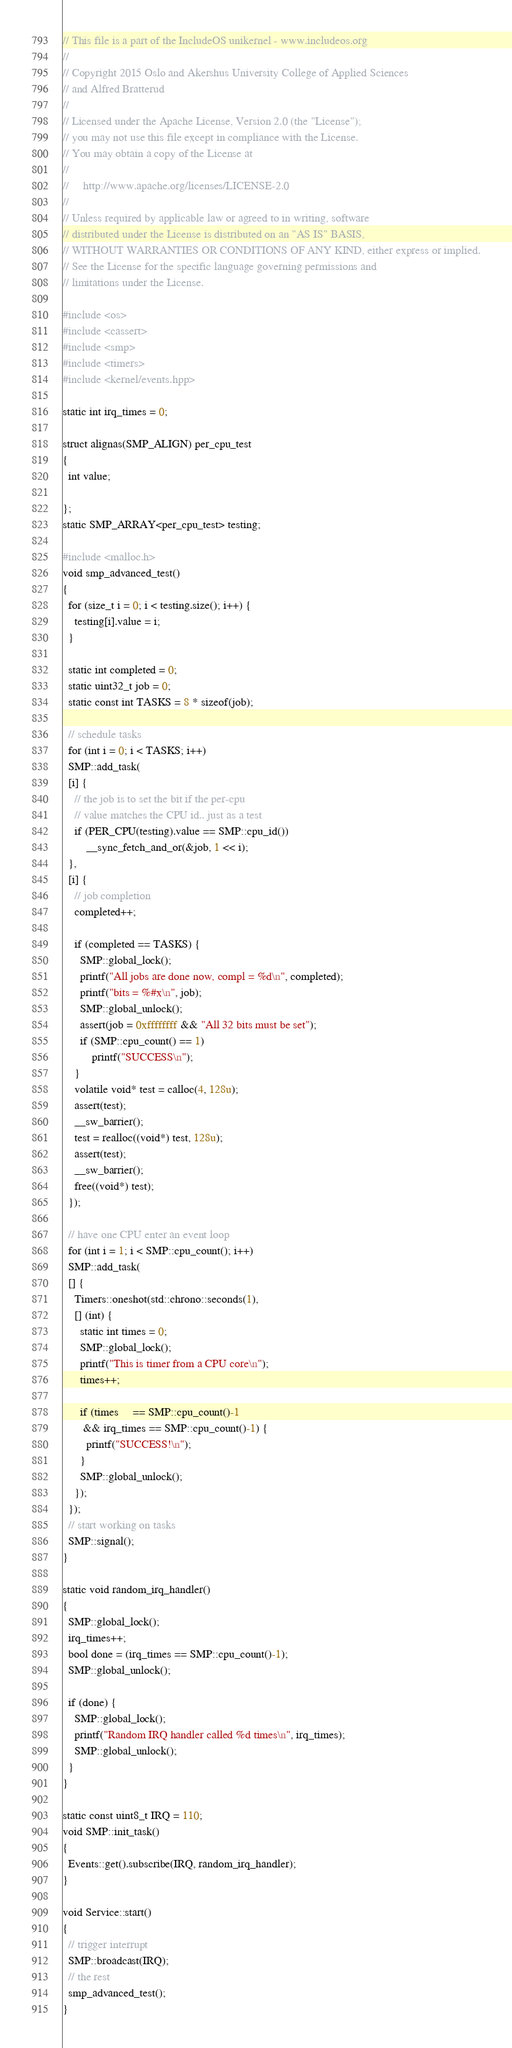Convert code to text. <code><loc_0><loc_0><loc_500><loc_500><_C++_>// This file is a part of the IncludeOS unikernel - www.includeos.org
//
// Copyright 2015 Oslo and Akershus University College of Applied Sciences
// and Alfred Bratterud
//
// Licensed under the Apache License, Version 2.0 (the "License");
// you may not use this file except in compliance with the License.
// You may obtain a copy of the License at
//
//     http://www.apache.org/licenses/LICENSE-2.0
//
// Unless required by applicable law or agreed to in writing, software
// distributed under the License is distributed on an "AS IS" BASIS,
// WITHOUT WARRANTIES OR CONDITIONS OF ANY KIND, either express or implied.
// See the License for the specific language governing permissions and
// limitations under the License.

#include <os>
#include <cassert>
#include <smp>
#include <timers>
#include <kernel/events.hpp>

static int irq_times = 0;

struct alignas(SMP_ALIGN) per_cpu_test
{
  int value;

};
static SMP_ARRAY<per_cpu_test> testing;

#include <malloc.h>
void smp_advanced_test()
{
  for (size_t i = 0; i < testing.size(); i++) {
    testing[i].value = i;
  }

  static int completed = 0;
  static uint32_t job = 0;
  static const int TASKS = 8 * sizeof(job);

  // schedule tasks
  for (int i = 0; i < TASKS; i++)
  SMP::add_task(
  [i] {
    // the job is to set the bit if the per-cpu
    // value matches the CPU id.. just as a test
    if (PER_CPU(testing).value == SMP::cpu_id())
        __sync_fetch_and_or(&job, 1 << i);
  },
  [i] {
    // job completion
    completed++;

    if (completed == TASKS) {
      SMP::global_lock();
      printf("All jobs are done now, compl = %d\n", completed);
      printf("bits = %#x\n", job);
      SMP::global_unlock();
      assert(job = 0xffffffff && "All 32 bits must be set");
      if (SMP::cpu_count() == 1)
          printf("SUCCESS\n");
    }
    volatile void* test = calloc(4, 128u);
    assert(test);
    __sw_barrier();
    test = realloc((void*) test, 128u);
    assert(test);
    __sw_barrier();
    free((void*) test);
  });

  // have one CPU enter an event loop
  for (int i = 1; i < SMP::cpu_count(); i++)
  SMP::add_task(
  [] {
    Timers::oneshot(std::chrono::seconds(1),
    [] (int) {
      static int times = 0;
      SMP::global_lock();
      printf("This is timer from a CPU core\n");
      times++;

      if (times     == SMP::cpu_count()-1
       && irq_times == SMP::cpu_count()-1) {
        printf("SUCCESS!\n");
      }
      SMP::global_unlock();
    });
  });
  // start working on tasks
  SMP::signal();
}

static void random_irq_handler()
{
  SMP::global_lock();
  irq_times++;
  bool done = (irq_times == SMP::cpu_count()-1);
  SMP::global_unlock();

  if (done) {
    SMP::global_lock();
    printf("Random IRQ handler called %d times\n", irq_times);
    SMP::global_unlock();
  }
}

static const uint8_t IRQ = 110;
void SMP::init_task()
{
  Events::get().subscribe(IRQ, random_irq_handler);
}

void Service::start()
{
  // trigger interrupt
  SMP::broadcast(IRQ);
  // the rest
  smp_advanced_test();
}
</code> 